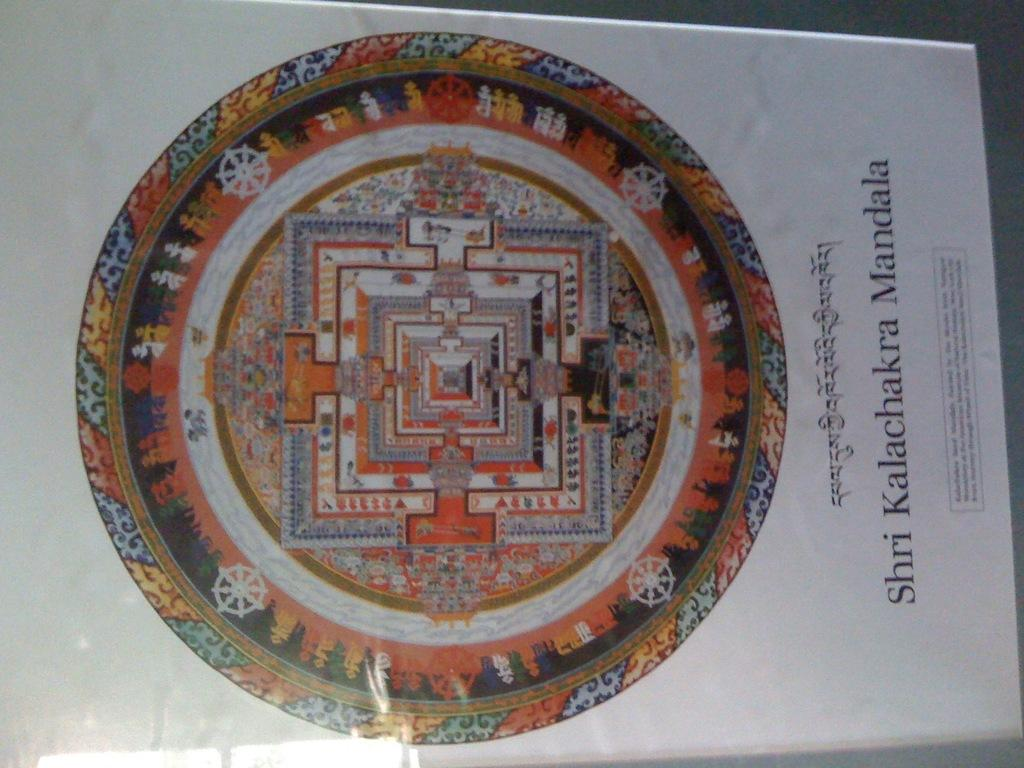<image>
Present a compact description of the photo's key features. A Buddhist symbol which is round in shape with tapestry designs and "Shiri Kalachakra Mandala" in print under the symbol along with some other script. 